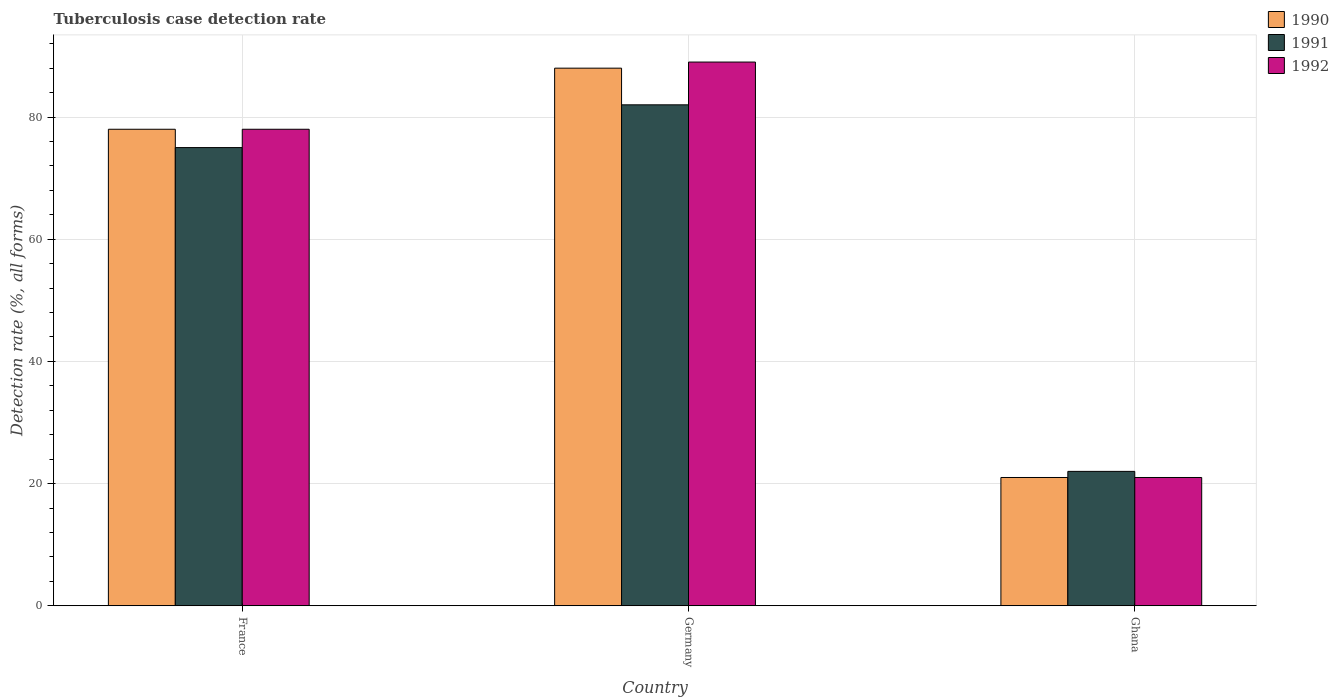How many different coloured bars are there?
Your response must be concise. 3. In how many cases, is the number of bars for a given country not equal to the number of legend labels?
Your answer should be compact. 0. Across all countries, what is the maximum tuberculosis case detection rate in in 1992?
Your response must be concise. 89. Across all countries, what is the minimum tuberculosis case detection rate in in 1991?
Your answer should be very brief. 22. In which country was the tuberculosis case detection rate in in 1992 maximum?
Provide a short and direct response. Germany. In which country was the tuberculosis case detection rate in in 1992 minimum?
Offer a terse response. Ghana. What is the total tuberculosis case detection rate in in 1990 in the graph?
Make the answer very short. 187. What is the average tuberculosis case detection rate in in 1990 per country?
Your answer should be very brief. 62.33. What is the ratio of the tuberculosis case detection rate in in 1992 in Germany to that in Ghana?
Offer a very short reply. 4.24. Is the difference between the tuberculosis case detection rate in in 1991 in France and Ghana greater than the difference between the tuberculosis case detection rate in in 1990 in France and Ghana?
Your answer should be very brief. No. What is the difference between the highest and the second highest tuberculosis case detection rate in in 1992?
Offer a very short reply. 68. What is the difference between the highest and the lowest tuberculosis case detection rate in in 1991?
Offer a terse response. 60. Is the sum of the tuberculosis case detection rate in in 1990 in France and Ghana greater than the maximum tuberculosis case detection rate in in 1991 across all countries?
Make the answer very short. Yes. What does the 2nd bar from the left in Ghana represents?
Your answer should be compact. 1991. What does the 1st bar from the right in France represents?
Offer a very short reply. 1992. Is it the case that in every country, the sum of the tuberculosis case detection rate in in 1992 and tuberculosis case detection rate in in 1990 is greater than the tuberculosis case detection rate in in 1991?
Your response must be concise. Yes. Are all the bars in the graph horizontal?
Your answer should be compact. No. How many countries are there in the graph?
Give a very brief answer. 3. What is the title of the graph?
Provide a succinct answer. Tuberculosis case detection rate. What is the label or title of the Y-axis?
Provide a short and direct response. Detection rate (%, all forms). What is the Detection rate (%, all forms) in 1991 in France?
Offer a terse response. 75. What is the Detection rate (%, all forms) in 1992 in Germany?
Keep it short and to the point. 89. What is the Detection rate (%, all forms) in 1991 in Ghana?
Your answer should be very brief. 22. What is the Detection rate (%, all forms) in 1992 in Ghana?
Your response must be concise. 21. Across all countries, what is the maximum Detection rate (%, all forms) of 1990?
Your answer should be compact. 88. Across all countries, what is the maximum Detection rate (%, all forms) in 1992?
Your response must be concise. 89. Across all countries, what is the minimum Detection rate (%, all forms) in 1990?
Your response must be concise. 21. What is the total Detection rate (%, all forms) in 1990 in the graph?
Your response must be concise. 187. What is the total Detection rate (%, all forms) in 1991 in the graph?
Provide a short and direct response. 179. What is the total Detection rate (%, all forms) in 1992 in the graph?
Keep it short and to the point. 188. What is the difference between the Detection rate (%, all forms) in 1991 in France and that in Germany?
Make the answer very short. -7. What is the difference between the Detection rate (%, all forms) of 1992 in France and that in Germany?
Your response must be concise. -11. What is the difference between the Detection rate (%, all forms) in 1991 in Germany and that in Ghana?
Offer a very short reply. 60. What is the difference between the Detection rate (%, all forms) in 1990 in France and the Detection rate (%, all forms) in 1992 in Ghana?
Provide a short and direct response. 57. What is the difference between the Detection rate (%, all forms) in 1991 in France and the Detection rate (%, all forms) in 1992 in Ghana?
Your answer should be very brief. 54. What is the difference between the Detection rate (%, all forms) of 1990 in Germany and the Detection rate (%, all forms) of 1991 in Ghana?
Offer a terse response. 66. What is the difference between the Detection rate (%, all forms) in 1990 in Germany and the Detection rate (%, all forms) in 1992 in Ghana?
Your answer should be compact. 67. What is the difference between the Detection rate (%, all forms) of 1991 in Germany and the Detection rate (%, all forms) of 1992 in Ghana?
Ensure brevity in your answer.  61. What is the average Detection rate (%, all forms) of 1990 per country?
Your answer should be compact. 62.33. What is the average Detection rate (%, all forms) of 1991 per country?
Provide a short and direct response. 59.67. What is the average Detection rate (%, all forms) of 1992 per country?
Provide a short and direct response. 62.67. What is the difference between the Detection rate (%, all forms) in 1990 and Detection rate (%, all forms) in 1991 in France?
Provide a succinct answer. 3. What is the difference between the Detection rate (%, all forms) in 1991 and Detection rate (%, all forms) in 1992 in France?
Provide a short and direct response. -3. What is the difference between the Detection rate (%, all forms) of 1990 and Detection rate (%, all forms) of 1992 in Germany?
Offer a very short reply. -1. What is the difference between the Detection rate (%, all forms) of 1991 and Detection rate (%, all forms) of 1992 in Germany?
Offer a terse response. -7. What is the difference between the Detection rate (%, all forms) in 1990 and Detection rate (%, all forms) in 1991 in Ghana?
Your response must be concise. -1. What is the ratio of the Detection rate (%, all forms) of 1990 in France to that in Germany?
Make the answer very short. 0.89. What is the ratio of the Detection rate (%, all forms) of 1991 in France to that in Germany?
Provide a succinct answer. 0.91. What is the ratio of the Detection rate (%, all forms) in 1992 in France to that in Germany?
Your answer should be very brief. 0.88. What is the ratio of the Detection rate (%, all forms) of 1990 in France to that in Ghana?
Provide a succinct answer. 3.71. What is the ratio of the Detection rate (%, all forms) of 1991 in France to that in Ghana?
Your answer should be very brief. 3.41. What is the ratio of the Detection rate (%, all forms) of 1992 in France to that in Ghana?
Your answer should be very brief. 3.71. What is the ratio of the Detection rate (%, all forms) of 1990 in Germany to that in Ghana?
Your answer should be very brief. 4.19. What is the ratio of the Detection rate (%, all forms) in 1991 in Germany to that in Ghana?
Provide a succinct answer. 3.73. What is the ratio of the Detection rate (%, all forms) of 1992 in Germany to that in Ghana?
Provide a short and direct response. 4.24. What is the difference between the highest and the second highest Detection rate (%, all forms) of 1990?
Provide a short and direct response. 10. What is the difference between the highest and the second highest Detection rate (%, all forms) in 1991?
Offer a very short reply. 7. What is the difference between the highest and the second highest Detection rate (%, all forms) in 1992?
Keep it short and to the point. 11. What is the difference between the highest and the lowest Detection rate (%, all forms) in 1990?
Provide a short and direct response. 67. What is the difference between the highest and the lowest Detection rate (%, all forms) of 1991?
Offer a very short reply. 60. 